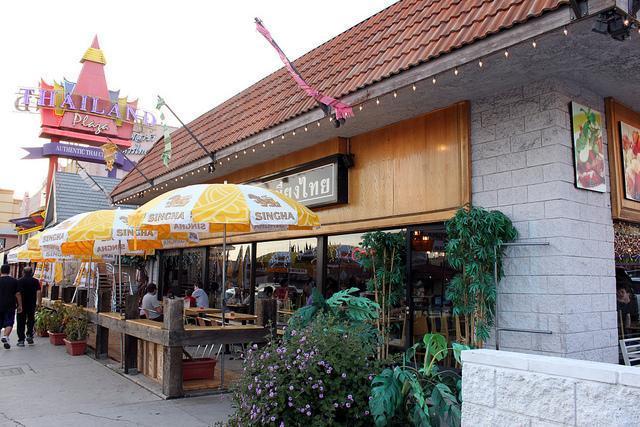How many umbrellas are in the picture?
Give a very brief answer. 2. How many potted plants can you see?
Give a very brief answer. 5. How many zebra heads can you see?
Give a very brief answer. 0. 